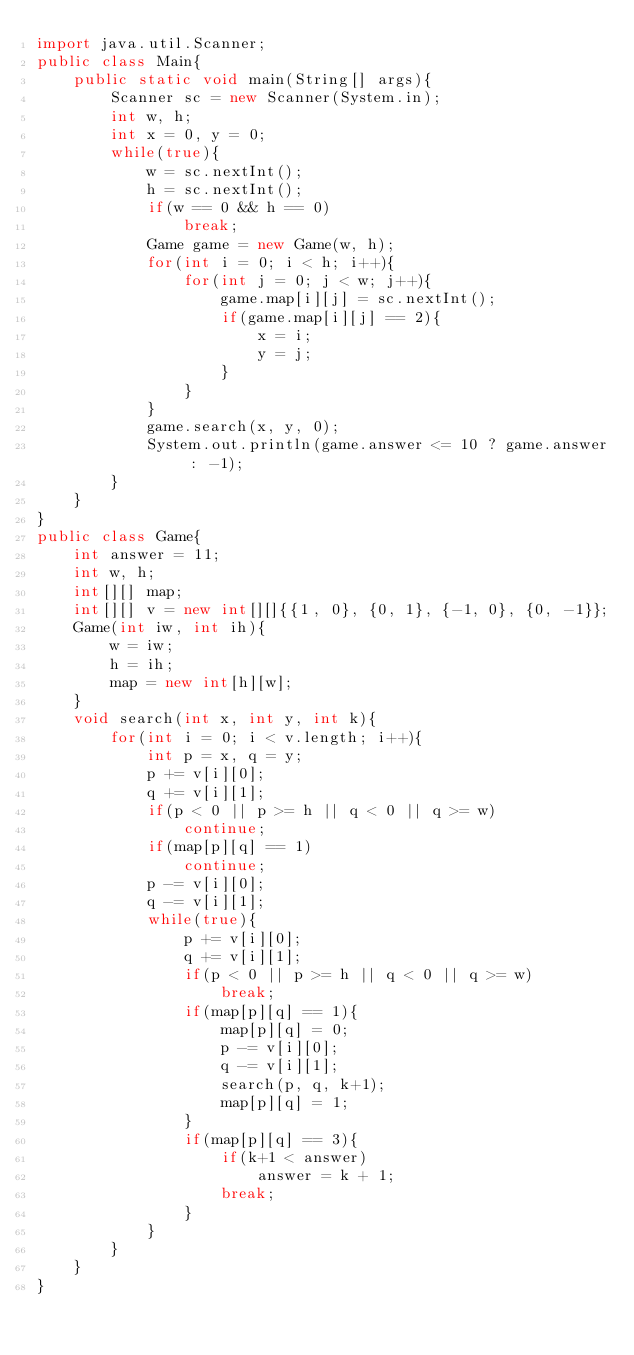<code> <loc_0><loc_0><loc_500><loc_500><_Java_>import java.util.Scanner;
public class Main{
	public static void main(String[] args){
		Scanner sc = new Scanner(System.in);
		int w, h;
		int x = 0, y = 0;
		while(true){
			w = sc.nextInt();
			h = sc.nextInt();
			if(w == 0 && h == 0)
				break;
			Game game = new Game(w, h);
			for(int i = 0; i < h; i++){
				for(int j = 0; j < w; j++){
					game.map[i][j] = sc.nextInt();
					if(game.map[i][j] == 2){
						x = i;
						y = j;
					}
				}
			}
			game.search(x, y, 0);
			System.out.println(game.answer <= 10 ? game.answer : -1);
		}
	}
}
public class Game{
	int answer = 11;
	int w, h;
	int[][] map;
	int[][] v = new int[][]{{1, 0}, {0, 1}, {-1, 0}, {0, -1}};
	Game(int iw, int ih){
		w = iw;
		h = ih;
		map = new int[h][w];
	}
	void search(int x, int y, int k){
		for(int i = 0; i < v.length; i++){
			int p = x, q = y;
			p += v[i][0];
			q += v[i][1];
			if(p < 0 || p >= h || q < 0 || q >= w)
				continue;
			if(map[p][q] == 1)
				continue;
			p -= v[i][0];
			q -= v[i][1];
			while(true){
				p += v[i][0];
				q += v[i][1];
				if(p < 0 || p >= h || q < 0 || q >= w)
					break;
				if(map[p][q] == 1){
					map[p][q] = 0;
					p -= v[i][0];
					q -= v[i][1];
					search(p, q, k+1);
					map[p][q] = 1;
				}	
				if(map[p][q] == 3){
					if(k+1 < answer)
						answer = k + 1;
					break;
				}
			}
		}
	}
}</code> 